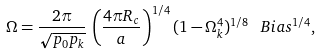<formula> <loc_0><loc_0><loc_500><loc_500>\Omega = \frac { 2 \pi } { \sqrt { p _ { 0 } p _ { k } } } \, \left ( \frac { 4 \pi R _ { c } } { a } \right ) ^ { 1 / 4 } ( 1 - \Omega _ { k } ^ { 4 } ) ^ { 1 / 8 } \, \ B i a s ^ { 1 / 4 } ,</formula> 